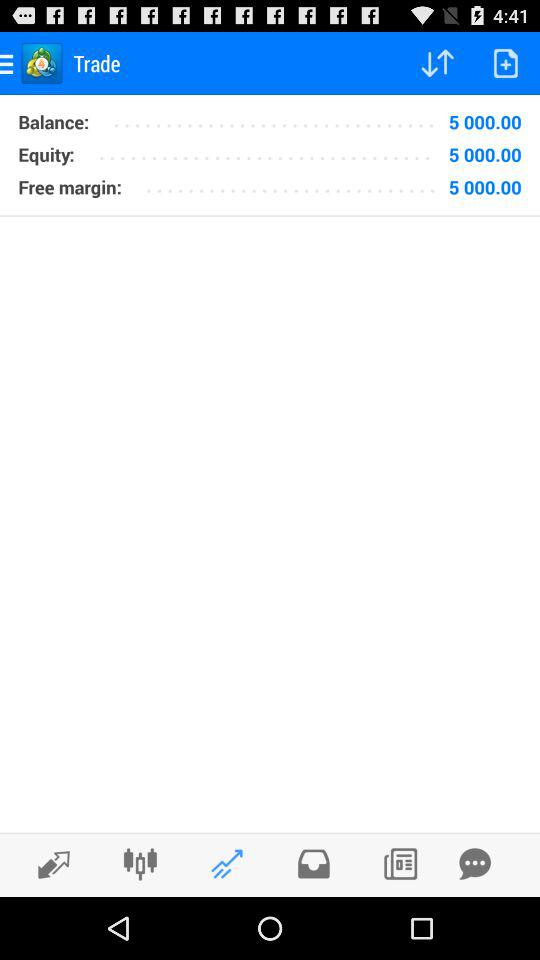What is the amount of equity? The amount of equity is 5000.00. 